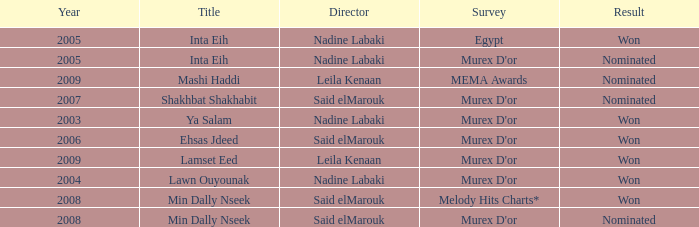What is the result for director Said Elmarouk before 2008? Won, Nominated. 